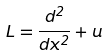Convert formula to latex. <formula><loc_0><loc_0><loc_500><loc_500>L = \frac { d ^ { 2 } } { d x ^ { 2 } } + u</formula> 